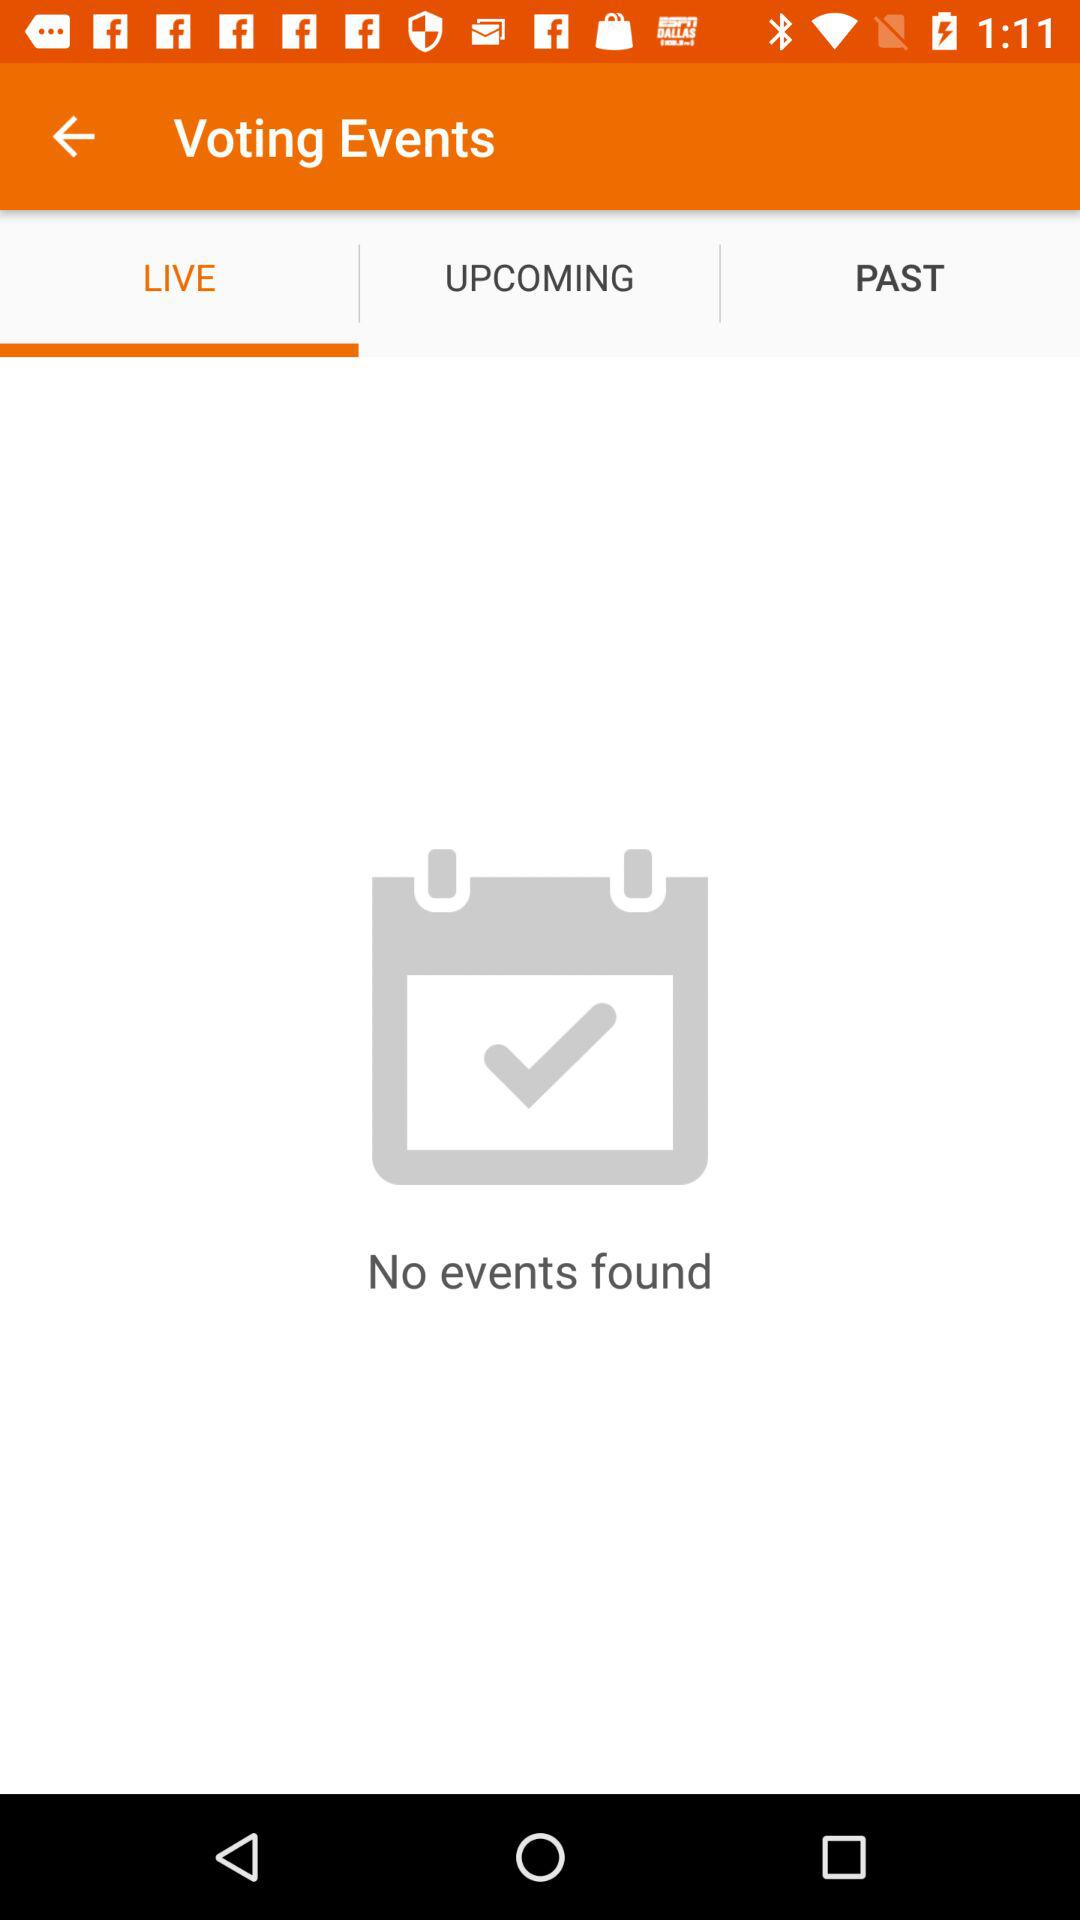Which tab is selected in voting events? The selected tab is "LIVE". 